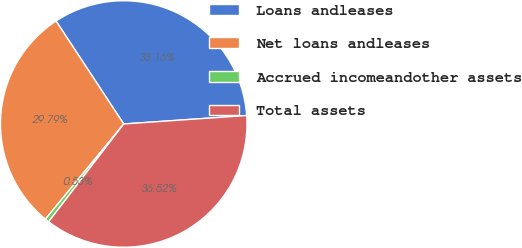Convert chart to OTSL. <chart><loc_0><loc_0><loc_500><loc_500><pie_chart><fcel>Loans andleases<fcel>Net loans andleases<fcel>Accrued incomeandother assets<fcel>Total assets<nl><fcel>33.16%<fcel>29.79%<fcel>0.53%<fcel>36.52%<nl></chart> 